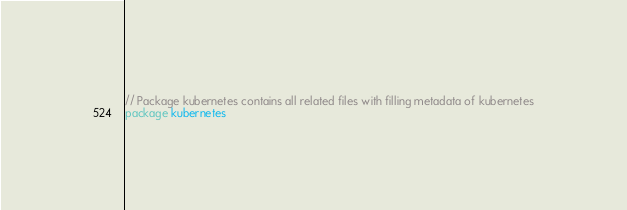Convert code to text. <code><loc_0><loc_0><loc_500><loc_500><_Go_>// Package kubernetes contains all related files with filling metadata of kubernetes
package kubernetes
</code> 